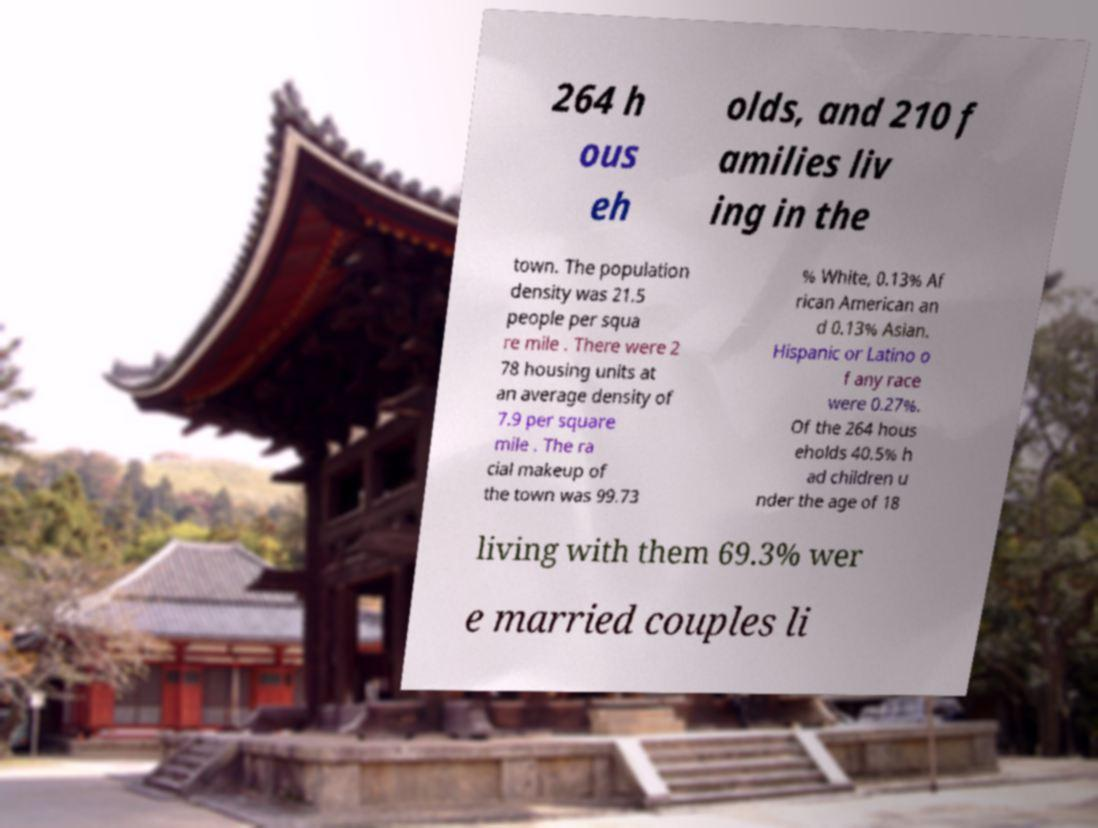For documentation purposes, I need the text within this image transcribed. Could you provide that? 264 h ous eh olds, and 210 f amilies liv ing in the town. The population density was 21.5 people per squa re mile . There were 2 78 housing units at an average density of 7.9 per square mile . The ra cial makeup of the town was 99.73 % White, 0.13% Af rican American an d 0.13% Asian. Hispanic or Latino o f any race were 0.27%. Of the 264 hous eholds 40.5% h ad children u nder the age of 18 living with them 69.3% wer e married couples li 